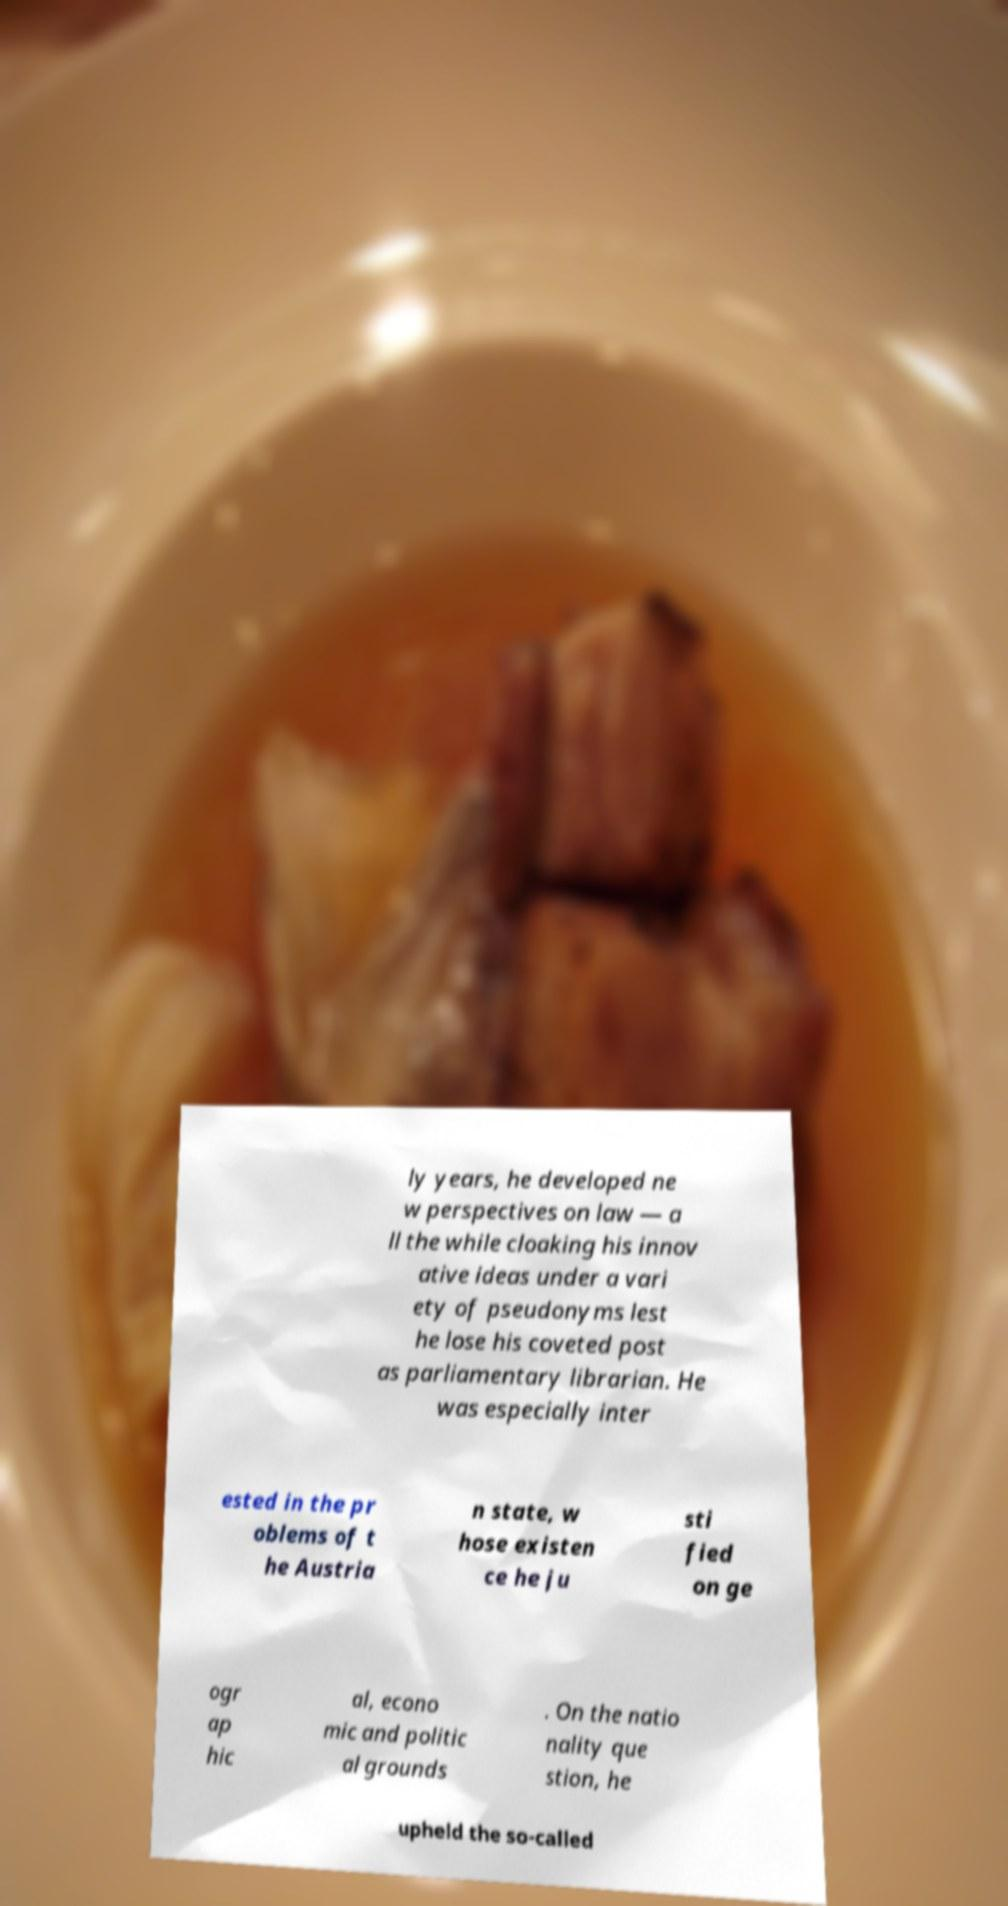Can you accurately transcribe the text from the provided image for me? ly years, he developed ne w perspectives on law — a ll the while cloaking his innov ative ideas under a vari ety of pseudonyms lest he lose his coveted post as parliamentary librarian. He was especially inter ested in the pr oblems of t he Austria n state, w hose existen ce he ju sti fied on ge ogr ap hic al, econo mic and politic al grounds . On the natio nality que stion, he upheld the so-called 